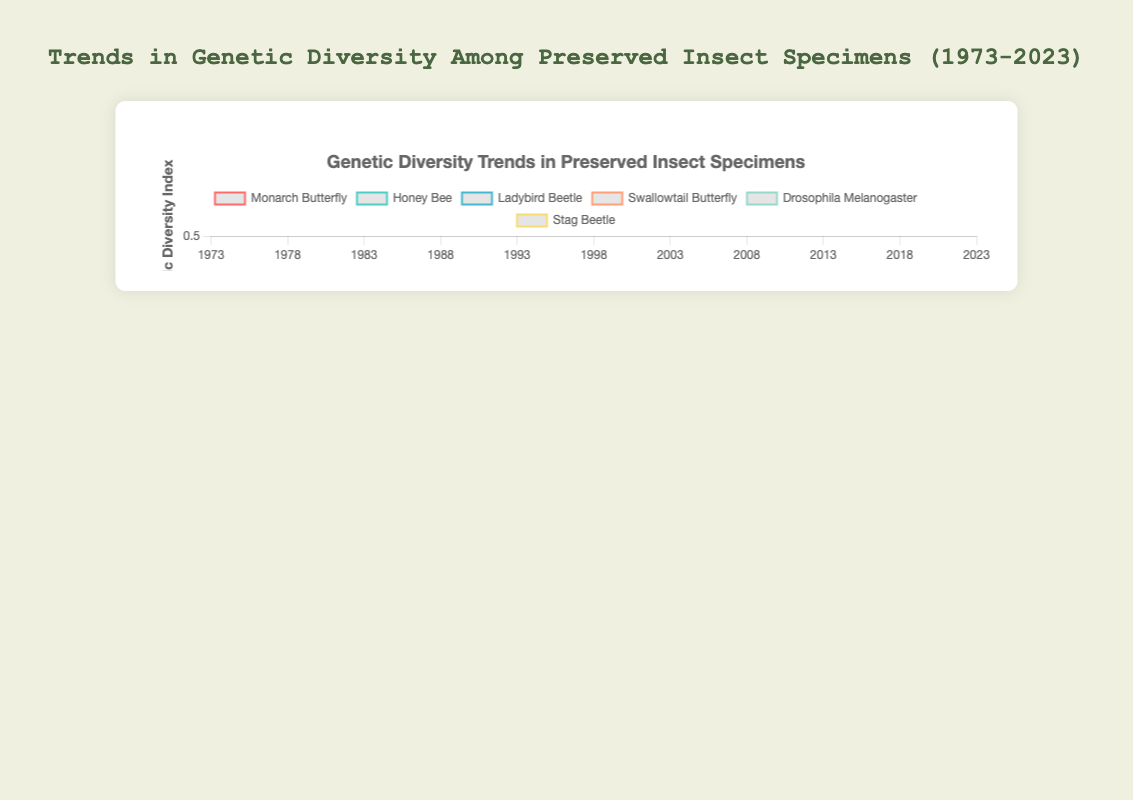Which species showed the largest decrease in genetic diversity over the past 50 years? To determine which species had the largest decrease, we need to find the difference between the initial and final values for each species. For Monarch Butterfly, the decrease is 0.85 - 0.58 = 0.27. For Honey Bee, the decrease is 0.78 - 0.55 = 0.23. For Ladybird Beetle, the decrease is 0.88 - 0.67 = 0.21. For Swallowtail Butterfly, the decrease is 0.91 - 0.68 = 0.23. For Drosophila Melanogaster, the decrease is 0.92 - 0.73 = 0.19. For Stag Beetle, the decrease is 0.83 - 0.60 = 0.23. Thus, the Monarch Butterfly showed the largest decrease.
Answer: Monarch Butterfly Between which years did the genetic diversity of Honey Bees decrease by the largest amount? To find this, we compare the differences between each pair of consecutive years. The largest decrease is between 2003 and 2008 where it went from 0.65 to 0.62, a decrease of 0.03. Other decreases: 0.02 (1973-1978), 0.02 (1978-1983), 0.02 (1983-1988), 0.02 (1988-1993), 0.02 (1993-1998), 0.03 (1998-2003), 0.02 (2008-2013), 0.02 (2013-2018), 0.03 (2018-2023).
Answer: 2003 to 2008 Which insect species had the highest genetic diversity in 2023? We compare the genetic diversity values in 2023 for all species. Monarch Butterfly: 0.58, Honey Bee: 0.55, Ladybird Beetle: 0.67, Swallowtail Butterfly: 0.68, Drosophila Melanogaster: 0.73, Stag Beetle: 0.60. The highest value is 0.73 for Drosophila Melanogaster.
Answer: Drosophila Melanogaster Across all species, what is the average genetic diversity index in 1993? First, get the 1993 values: Monarch Butterfly: 0.75, Honey Bee: 0.70, Ladybird Beetle: 0.81, Swallowtail Butterfly: 0.82, Drosophila Melanogaster: 0.84, Stag Beetle: 0.74. Sum these values: 0.75 + 0.70 + 0.81 + 0.82 + 0.84 + 0.74 = 4.66. Divide by the number of species (6): 4.66 / 6 = 0.7767
Answer: 0.7767 What is the trend in genetic diversity for Swallowtail Butterfly over the entire 50 years? Observing the values from 1973 to 2023 for Swallowtail Butterfly: 0.91, 0.89, 0.87, 0.85, 0.82, 0.80, 0.78, 0.75, 0.73, 0.70, 0.68, we see a steady decline.
Answer: Decrease Comparing the genetic diversity of Monarch Butterfly and Honey Bee in 1983, which one had a higher index? In 1983, Monarch Butterfly had 0.79 and Honey Bee had 0.74.
Answer: Monarch Butterfly What is the average genetic diversity index for Drosophila Melanogaster from 1973 to 2023? Obtain the Drosophila Melanogaster values: 0.92, 0.90, 0.88, 0.86, 0.84, 0.83, 0.81, 0.79, 0.77, 0.75, 0.73. Sum these values: 0.92 + 0.90 + 0.88 + 0.86 + 0.84 + 0.83 + 0.81 + 0.79 + 0.77 + 0.75 + 0.73 = 9.08. Divide by the number of years (11): 9.08 / 11 = 0.825
Answer: 0.825 Which species had the closest genetic diversity index values in 2023? Compare the 2023 values: Monarch Butterfly: 0.58, Honey Bee: 0.55, Ladybird Beetle: 0.67, Swallowtail Butterfly: 0.68, Drosophila Melanogaster: 0.73, Stag Beetle: 0.60. The closest values are Monarch Butterfly (0.58) and Stag Beetle (0.60), with a difference of 0.02.
Answer: Monarch Butterfly and Stag Beetle What is the rate of change in genetic diversity for Swallowtail Butterfly from 1973 to 2023? Calculate the rate of change for Swallowtail Butterfly. Initial value: 0.91 (1973), final value: 0.68 (2023). Rate of change: (0.68 - 0.91) / (2023 - 1973) = -0.23 / 50 ≈ -0.0046 per year
Answer: -0.0046 per year 